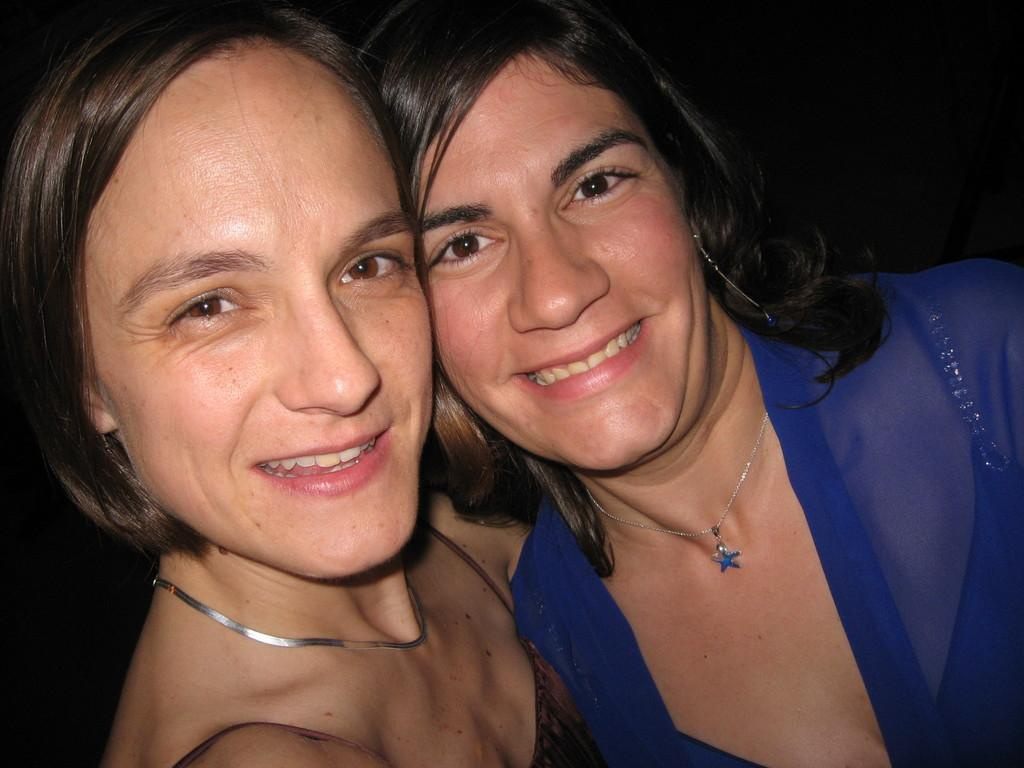How many people are in the image? There are two women in the image. What are the women doing in the image? The women are posing for a photo. Can you describe the background of the image? The background of the image is dark. What type of discovery can be seen in the background of the image? There is no discovery present in the image; the background is dark. What type of bottle is being held by one of the women in the image? There is no bottle present in the image. 